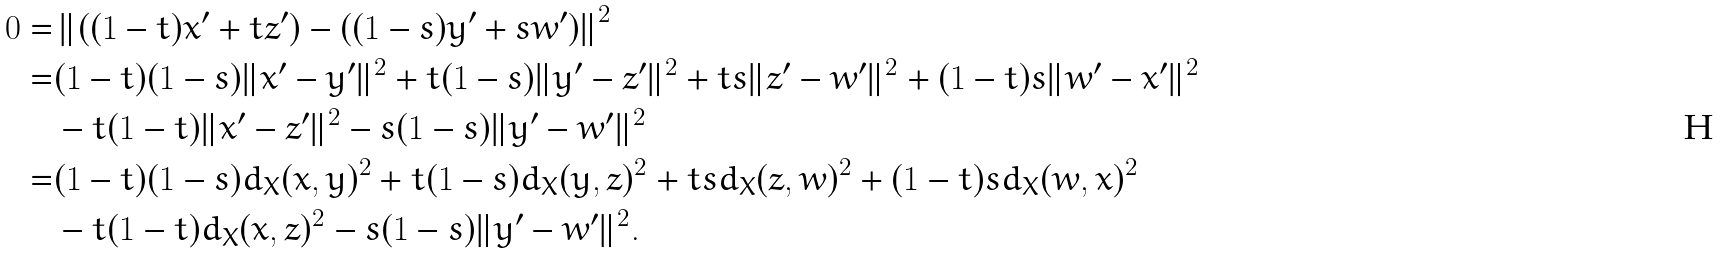Convert formula to latex. <formula><loc_0><loc_0><loc_500><loc_500>0 = & \left \| \left ( ( 1 - t ) x ^ { \prime } + t z ^ { \prime } \right ) - \left ( ( 1 - s ) y ^ { \prime } + s w ^ { \prime } \right ) \right \| ^ { 2 } \\ = & ( 1 - t ) ( 1 - s ) \| x ^ { \prime } - y ^ { \prime } \| ^ { 2 } + t ( 1 - s ) \| y ^ { \prime } - z ^ { \prime } \| ^ { 2 } + t s \| z ^ { \prime } - w ^ { \prime } \| ^ { 2 } + ( 1 - t ) s \| w ^ { \prime } - x ^ { \prime } \| ^ { 2 } \\ & - t ( 1 - t ) \| x ^ { \prime } - z ^ { \prime } \| ^ { 2 } - s ( 1 - s ) \| y ^ { \prime } - w ^ { \prime } \| ^ { 2 } \\ = & ( 1 - t ) ( 1 - s ) d _ { X } ( x , y ) ^ { 2 } + t ( 1 - s ) d _ { X } ( y , z ) ^ { 2 } + t s d _ { X } ( z , w ) ^ { 2 } + ( 1 - t ) s d _ { X } ( w , x ) ^ { 2 } \\ & - t ( 1 - t ) d _ { X } ( x , z ) ^ { 2 } - s ( 1 - s ) \| y ^ { \prime } - w ^ { \prime } \| ^ { 2 } .</formula> 